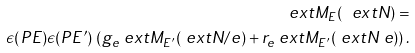Convert formula to latex. <formula><loc_0><loc_0><loc_500><loc_500>\ e x t { M } _ { E } ( \ e x t { N } ) = \\ \epsilon ( P E ) \epsilon ( P E ^ { \prime } ) \, \left ( g _ { e } \ e x t { M } _ { E ^ { \prime } } ( \ e x t { N } / e ) + r _ { e } \ e x t { M } _ { E ^ { \prime } } ( \ e x t { N } \ e ) \right ) .</formula> 